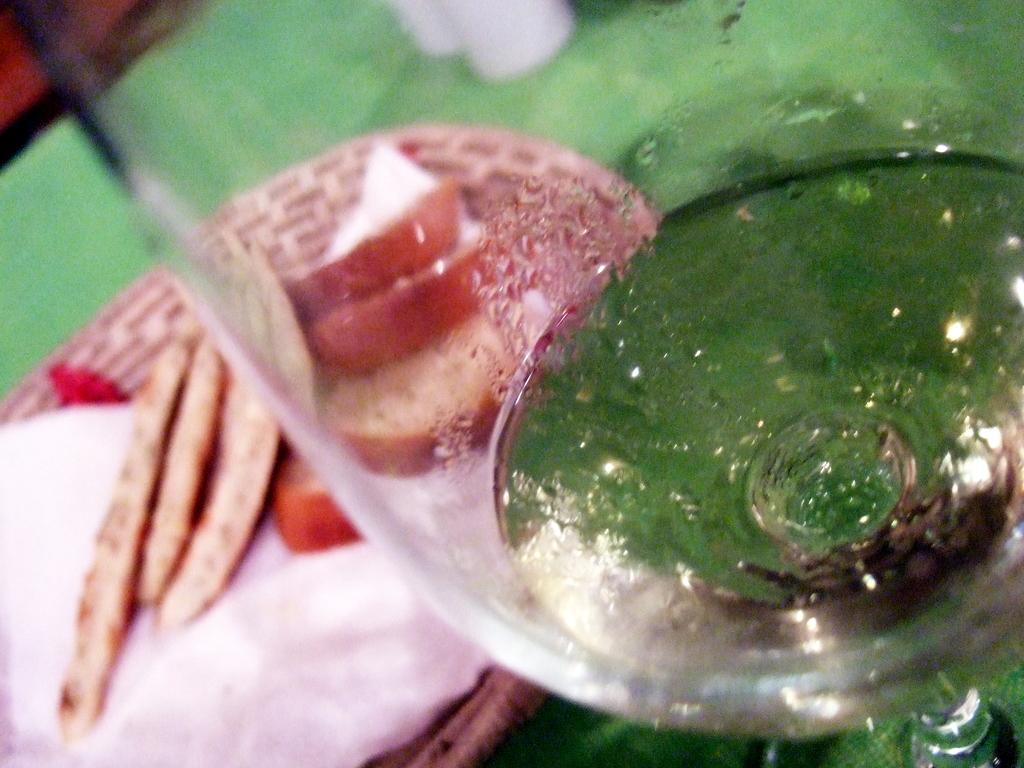What type of container is visible in the image? There is a glass in the image. What other object is present in the image? There is a plate in the image. What is on the plate? The plate contains food items. What is the color of the surface on which the glass and plate are placed? The glass and plate are placed on a green surface. How many people are visible in the image? There are no people visible in the image. What type of needle is being used to sew the fabric in the image? There is no fabric or needle present in the image. 